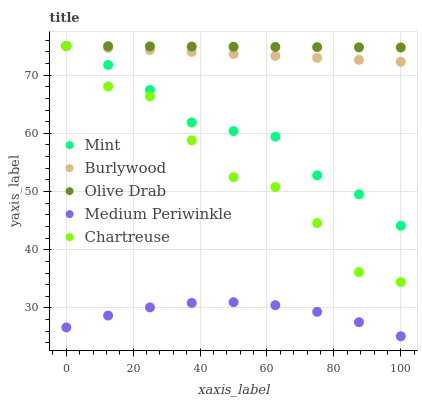Does Medium Periwinkle have the minimum area under the curve?
Answer yes or no. Yes. Does Olive Drab have the maximum area under the curve?
Answer yes or no. Yes. Does Chartreuse have the minimum area under the curve?
Answer yes or no. No. Does Chartreuse have the maximum area under the curve?
Answer yes or no. No. Is Burlywood the smoothest?
Answer yes or no. Yes. Is Chartreuse the roughest?
Answer yes or no. Yes. Is Medium Periwinkle the smoothest?
Answer yes or no. No. Is Medium Periwinkle the roughest?
Answer yes or no. No. Does Medium Periwinkle have the lowest value?
Answer yes or no. Yes. Does Chartreuse have the lowest value?
Answer yes or no. No. Does Olive Drab have the highest value?
Answer yes or no. Yes. Does Medium Periwinkle have the highest value?
Answer yes or no. No. Is Medium Periwinkle less than Burlywood?
Answer yes or no. Yes. Is Chartreuse greater than Medium Periwinkle?
Answer yes or no. Yes. Does Olive Drab intersect Burlywood?
Answer yes or no. Yes. Is Olive Drab less than Burlywood?
Answer yes or no. No. Is Olive Drab greater than Burlywood?
Answer yes or no. No. Does Medium Periwinkle intersect Burlywood?
Answer yes or no. No. 